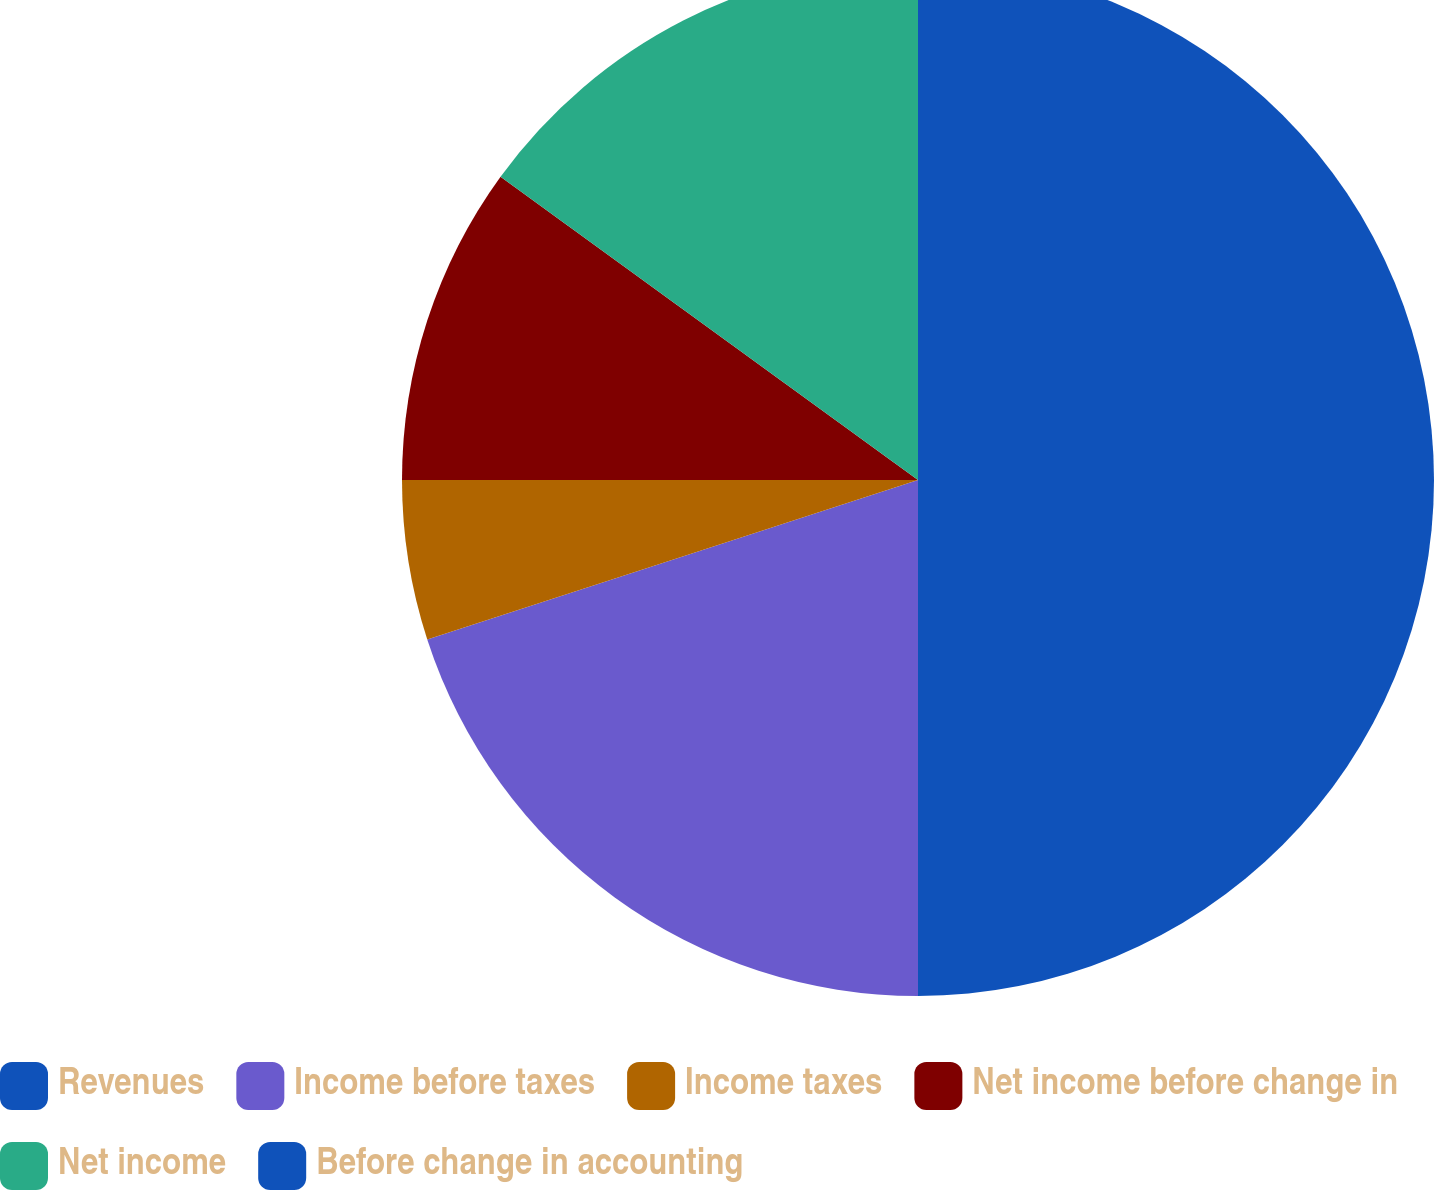Convert chart. <chart><loc_0><loc_0><loc_500><loc_500><pie_chart><fcel>Revenues<fcel>Income before taxes<fcel>Income taxes<fcel>Net income before change in<fcel>Net income<fcel>Before change in accounting<nl><fcel>50.0%<fcel>20.0%<fcel>5.0%<fcel>10.0%<fcel>15.0%<fcel>0.0%<nl></chart> 